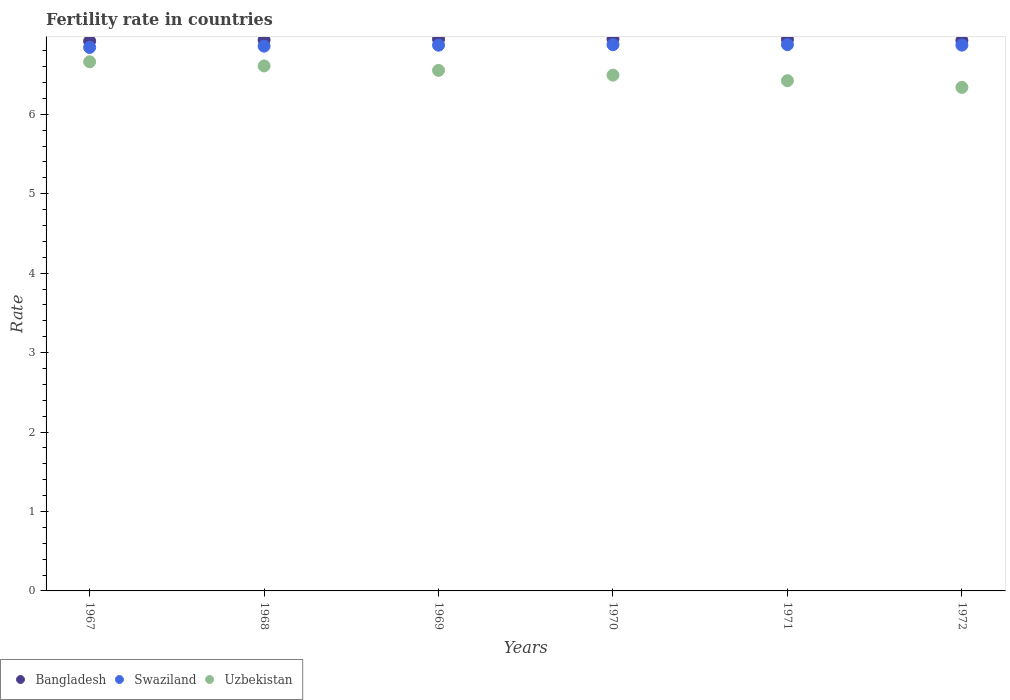How many different coloured dotlines are there?
Offer a very short reply. 3. What is the fertility rate in Uzbekistan in 1968?
Keep it short and to the point. 6.61. Across all years, what is the maximum fertility rate in Bangladesh?
Provide a short and direct response. 6.95. Across all years, what is the minimum fertility rate in Swaziland?
Your answer should be compact. 6.84. In which year was the fertility rate in Swaziland maximum?
Keep it short and to the point. 1971. In which year was the fertility rate in Swaziland minimum?
Your answer should be compact. 1967. What is the total fertility rate in Swaziland in the graph?
Ensure brevity in your answer.  41.19. What is the difference between the fertility rate in Uzbekistan in 1969 and that in 1971?
Give a very brief answer. 0.13. What is the difference between the fertility rate in Uzbekistan in 1969 and the fertility rate in Bangladesh in 1970?
Make the answer very short. -0.4. What is the average fertility rate in Swaziland per year?
Offer a terse response. 6.86. In the year 1971, what is the difference between the fertility rate in Uzbekistan and fertility rate in Swaziland?
Your answer should be compact. -0.45. In how many years, is the fertility rate in Bangladesh greater than 2.6?
Your answer should be very brief. 6. What is the ratio of the fertility rate in Uzbekistan in 1967 to that in 1970?
Your answer should be very brief. 1.03. Is the fertility rate in Bangladesh in 1967 less than that in 1972?
Your response must be concise. Yes. Is the difference between the fertility rate in Uzbekistan in 1968 and 1971 greater than the difference between the fertility rate in Swaziland in 1968 and 1971?
Your answer should be compact. Yes. What is the difference between the highest and the second highest fertility rate in Uzbekistan?
Give a very brief answer. 0.05. What is the difference between the highest and the lowest fertility rate in Swaziland?
Make the answer very short. 0.04. Is the sum of the fertility rate in Uzbekistan in 1967 and 1970 greater than the maximum fertility rate in Bangladesh across all years?
Ensure brevity in your answer.  Yes. Does the fertility rate in Uzbekistan monotonically increase over the years?
Your answer should be very brief. No. How many dotlines are there?
Your answer should be compact. 3. Are the values on the major ticks of Y-axis written in scientific E-notation?
Keep it short and to the point. No. Does the graph contain any zero values?
Offer a terse response. No. How many legend labels are there?
Keep it short and to the point. 3. What is the title of the graph?
Keep it short and to the point. Fertility rate in countries. What is the label or title of the X-axis?
Give a very brief answer. Years. What is the label or title of the Y-axis?
Provide a short and direct response. Rate. What is the Rate of Bangladesh in 1967?
Offer a terse response. 6.92. What is the Rate of Swaziland in 1967?
Ensure brevity in your answer.  6.84. What is the Rate of Uzbekistan in 1967?
Your answer should be very brief. 6.66. What is the Rate of Bangladesh in 1968?
Ensure brevity in your answer.  6.93. What is the Rate of Swaziland in 1968?
Provide a short and direct response. 6.86. What is the Rate in Uzbekistan in 1968?
Your answer should be very brief. 6.61. What is the Rate in Bangladesh in 1969?
Ensure brevity in your answer.  6.95. What is the Rate of Swaziland in 1969?
Your answer should be compact. 6.87. What is the Rate in Uzbekistan in 1969?
Give a very brief answer. 6.55. What is the Rate in Bangladesh in 1970?
Make the answer very short. 6.95. What is the Rate in Swaziland in 1970?
Offer a terse response. 6.88. What is the Rate in Uzbekistan in 1970?
Your answer should be very brief. 6.49. What is the Rate in Bangladesh in 1971?
Provide a short and direct response. 6.94. What is the Rate in Swaziland in 1971?
Offer a very short reply. 6.88. What is the Rate in Uzbekistan in 1971?
Ensure brevity in your answer.  6.42. What is the Rate of Bangladesh in 1972?
Keep it short and to the point. 6.93. What is the Rate of Swaziland in 1972?
Keep it short and to the point. 6.87. What is the Rate of Uzbekistan in 1972?
Provide a short and direct response. 6.34. Across all years, what is the maximum Rate in Bangladesh?
Offer a very short reply. 6.95. Across all years, what is the maximum Rate in Swaziland?
Your answer should be very brief. 6.88. Across all years, what is the maximum Rate of Uzbekistan?
Give a very brief answer. 6.66. Across all years, what is the minimum Rate in Bangladesh?
Provide a short and direct response. 6.92. Across all years, what is the minimum Rate of Swaziland?
Keep it short and to the point. 6.84. Across all years, what is the minimum Rate of Uzbekistan?
Your answer should be very brief. 6.34. What is the total Rate of Bangladesh in the graph?
Provide a succinct answer. 41.62. What is the total Rate of Swaziland in the graph?
Your response must be concise. 41.19. What is the total Rate of Uzbekistan in the graph?
Offer a terse response. 39.07. What is the difference between the Rate in Bangladesh in 1967 and that in 1968?
Keep it short and to the point. -0.01. What is the difference between the Rate of Swaziland in 1967 and that in 1968?
Your answer should be very brief. -0.02. What is the difference between the Rate of Uzbekistan in 1967 and that in 1968?
Keep it short and to the point. 0.05. What is the difference between the Rate in Bangladesh in 1967 and that in 1969?
Provide a succinct answer. -0.03. What is the difference between the Rate in Swaziland in 1967 and that in 1969?
Offer a very short reply. -0.03. What is the difference between the Rate of Uzbekistan in 1967 and that in 1969?
Your answer should be compact. 0.11. What is the difference between the Rate of Bangladesh in 1967 and that in 1970?
Provide a succinct answer. -0.03. What is the difference between the Rate of Swaziland in 1967 and that in 1970?
Your response must be concise. -0.03. What is the difference between the Rate of Uzbekistan in 1967 and that in 1970?
Give a very brief answer. 0.17. What is the difference between the Rate of Bangladesh in 1967 and that in 1971?
Your response must be concise. -0.02. What is the difference between the Rate in Swaziland in 1967 and that in 1971?
Offer a terse response. -0.04. What is the difference between the Rate of Uzbekistan in 1967 and that in 1971?
Your answer should be compact. 0.24. What is the difference between the Rate of Bangladesh in 1967 and that in 1972?
Your answer should be compact. -0.01. What is the difference between the Rate in Swaziland in 1967 and that in 1972?
Provide a succinct answer. -0.03. What is the difference between the Rate in Uzbekistan in 1967 and that in 1972?
Ensure brevity in your answer.  0.32. What is the difference between the Rate in Bangladesh in 1968 and that in 1969?
Provide a short and direct response. -0.01. What is the difference between the Rate of Swaziland in 1968 and that in 1969?
Ensure brevity in your answer.  -0.01. What is the difference between the Rate in Uzbekistan in 1968 and that in 1969?
Offer a very short reply. 0.06. What is the difference between the Rate of Bangladesh in 1968 and that in 1970?
Provide a short and direct response. -0.01. What is the difference between the Rate in Swaziland in 1968 and that in 1970?
Your answer should be compact. -0.02. What is the difference between the Rate in Uzbekistan in 1968 and that in 1970?
Offer a very short reply. 0.12. What is the difference between the Rate of Bangladesh in 1968 and that in 1971?
Offer a very short reply. -0.01. What is the difference between the Rate of Swaziland in 1968 and that in 1971?
Provide a short and direct response. -0.02. What is the difference between the Rate in Uzbekistan in 1968 and that in 1971?
Offer a very short reply. 0.19. What is the difference between the Rate in Bangladesh in 1968 and that in 1972?
Your response must be concise. 0.01. What is the difference between the Rate in Swaziland in 1968 and that in 1972?
Provide a succinct answer. -0.01. What is the difference between the Rate of Uzbekistan in 1968 and that in 1972?
Offer a terse response. 0.27. What is the difference between the Rate of Bangladesh in 1969 and that in 1970?
Give a very brief answer. -0. What is the difference between the Rate of Swaziland in 1969 and that in 1970?
Your answer should be very brief. -0.01. What is the difference between the Rate in Uzbekistan in 1969 and that in 1970?
Make the answer very short. 0.06. What is the difference between the Rate in Bangladesh in 1969 and that in 1971?
Keep it short and to the point. 0. What is the difference between the Rate of Swaziland in 1969 and that in 1971?
Provide a short and direct response. -0.01. What is the difference between the Rate of Uzbekistan in 1969 and that in 1971?
Offer a terse response. 0.13. What is the difference between the Rate in Bangladesh in 1969 and that in 1972?
Provide a succinct answer. 0.02. What is the difference between the Rate in Swaziland in 1969 and that in 1972?
Ensure brevity in your answer.  -0. What is the difference between the Rate in Uzbekistan in 1969 and that in 1972?
Make the answer very short. 0.21. What is the difference between the Rate in Bangladesh in 1970 and that in 1971?
Your answer should be very brief. 0.01. What is the difference between the Rate of Swaziland in 1970 and that in 1971?
Offer a terse response. -0. What is the difference between the Rate in Uzbekistan in 1970 and that in 1971?
Offer a very short reply. 0.07. What is the difference between the Rate of Bangladesh in 1970 and that in 1972?
Your answer should be very brief. 0.02. What is the difference between the Rate of Swaziland in 1970 and that in 1972?
Ensure brevity in your answer.  0.01. What is the difference between the Rate of Uzbekistan in 1970 and that in 1972?
Your answer should be compact. 0.15. What is the difference between the Rate of Bangladesh in 1971 and that in 1972?
Ensure brevity in your answer.  0.01. What is the difference between the Rate of Swaziland in 1971 and that in 1972?
Your answer should be very brief. 0.01. What is the difference between the Rate in Uzbekistan in 1971 and that in 1972?
Your answer should be compact. 0.08. What is the difference between the Rate of Bangladesh in 1967 and the Rate of Swaziland in 1968?
Give a very brief answer. 0.06. What is the difference between the Rate of Bangladesh in 1967 and the Rate of Uzbekistan in 1968?
Make the answer very short. 0.31. What is the difference between the Rate of Swaziland in 1967 and the Rate of Uzbekistan in 1968?
Your answer should be compact. 0.23. What is the difference between the Rate of Bangladesh in 1967 and the Rate of Swaziland in 1969?
Offer a very short reply. 0.05. What is the difference between the Rate of Bangladesh in 1967 and the Rate of Uzbekistan in 1969?
Keep it short and to the point. 0.37. What is the difference between the Rate in Swaziland in 1967 and the Rate in Uzbekistan in 1969?
Offer a terse response. 0.29. What is the difference between the Rate in Bangladesh in 1967 and the Rate in Swaziland in 1970?
Your answer should be very brief. 0.04. What is the difference between the Rate in Bangladesh in 1967 and the Rate in Uzbekistan in 1970?
Ensure brevity in your answer.  0.43. What is the difference between the Rate in Swaziland in 1967 and the Rate in Uzbekistan in 1970?
Offer a terse response. 0.35. What is the difference between the Rate in Bangladesh in 1967 and the Rate in Swaziland in 1971?
Provide a succinct answer. 0.04. What is the difference between the Rate in Bangladesh in 1967 and the Rate in Uzbekistan in 1971?
Ensure brevity in your answer.  0.5. What is the difference between the Rate in Swaziland in 1967 and the Rate in Uzbekistan in 1971?
Offer a very short reply. 0.42. What is the difference between the Rate in Bangladesh in 1967 and the Rate in Swaziland in 1972?
Ensure brevity in your answer.  0.05. What is the difference between the Rate in Bangladesh in 1967 and the Rate in Uzbekistan in 1972?
Ensure brevity in your answer.  0.58. What is the difference between the Rate in Swaziland in 1967 and the Rate in Uzbekistan in 1972?
Ensure brevity in your answer.  0.5. What is the difference between the Rate in Bangladesh in 1968 and the Rate in Swaziland in 1969?
Your response must be concise. 0.07. What is the difference between the Rate of Bangladesh in 1968 and the Rate of Uzbekistan in 1969?
Offer a very short reply. 0.38. What is the difference between the Rate of Swaziland in 1968 and the Rate of Uzbekistan in 1969?
Offer a very short reply. 0.3. What is the difference between the Rate of Bangladesh in 1968 and the Rate of Swaziland in 1970?
Offer a very short reply. 0.06. What is the difference between the Rate of Bangladesh in 1968 and the Rate of Uzbekistan in 1970?
Offer a very short reply. 0.44. What is the difference between the Rate of Swaziland in 1968 and the Rate of Uzbekistan in 1970?
Provide a succinct answer. 0.36. What is the difference between the Rate in Bangladesh in 1968 and the Rate in Swaziland in 1971?
Your answer should be very brief. 0.06. What is the difference between the Rate of Bangladesh in 1968 and the Rate of Uzbekistan in 1971?
Give a very brief answer. 0.51. What is the difference between the Rate in Swaziland in 1968 and the Rate in Uzbekistan in 1971?
Make the answer very short. 0.43. What is the difference between the Rate in Bangladesh in 1968 and the Rate in Swaziland in 1972?
Give a very brief answer. 0.07. What is the difference between the Rate in Bangladesh in 1968 and the Rate in Uzbekistan in 1972?
Offer a terse response. 0.6. What is the difference between the Rate of Swaziland in 1968 and the Rate of Uzbekistan in 1972?
Your answer should be compact. 0.52. What is the difference between the Rate of Bangladesh in 1969 and the Rate of Swaziland in 1970?
Give a very brief answer. 0.07. What is the difference between the Rate in Bangladesh in 1969 and the Rate in Uzbekistan in 1970?
Your answer should be very brief. 0.45. What is the difference between the Rate in Swaziland in 1969 and the Rate in Uzbekistan in 1970?
Your response must be concise. 0.38. What is the difference between the Rate of Bangladesh in 1969 and the Rate of Swaziland in 1971?
Your answer should be compact. 0.07. What is the difference between the Rate of Bangladesh in 1969 and the Rate of Uzbekistan in 1971?
Make the answer very short. 0.52. What is the difference between the Rate in Swaziland in 1969 and the Rate in Uzbekistan in 1971?
Offer a terse response. 0.45. What is the difference between the Rate in Bangladesh in 1969 and the Rate in Swaziland in 1972?
Make the answer very short. 0.07. What is the difference between the Rate of Bangladesh in 1969 and the Rate of Uzbekistan in 1972?
Offer a very short reply. 0.61. What is the difference between the Rate of Swaziland in 1969 and the Rate of Uzbekistan in 1972?
Give a very brief answer. 0.53. What is the difference between the Rate of Bangladesh in 1970 and the Rate of Swaziland in 1971?
Provide a succinct answer. 0.07. What is the difference between the Rate of Bangladesh in 1970 and the Rate of Uzbekistan in 1971?
Your response must be concise. 0.53. What is the difference between the Rate of Swaziland in 1970 and the Rate of Uzbekistan in 1971?
Provide a short and direct response. 0.45. What is the difference between the Rate of Bangladesh in 1970 and the Rate of Swaziland in 1972?
Give a very brief answer. 0.08. What is the difference between the Rate in Bangladesh in 1970 and the Rate in Uzbekistan in 1972?
Give a very brief answer. 0.61. What is the difference between the Rate of Swaziland in 1970 and the Rate of Uzbekistan in 1972?
Make the answer very short. 0.54. What is the difference between the Rate in Bangladesh in 1971 and the Rate in Swaziland in 1972?
Your answer should be compact. 0.07. What is the difference between the Rate of Bangladesh in 1971 and the Rate of Uzbekistan in 1972?
Ensure brevity in your answer.  0.6. What is the difference between the Rate of Swaziland in 1971 and the Rate of Uzbekistan in 1972?
Make the answer very short. 0.54. What is the average Rate in Bangladesh per year?
Provide a short and direct response. 6.94. What is the average Rate in Swaziland per year?
Provide a short and direct response. 6.86. What is the average Rate in Uzbekistan per year?
Ensure brevity in your answer.  6.51. In the year 1967, what is the difference between the Rate in Bangladesh and Rate in Swaziland?
Offer a very short reply. 0.08. In the year 1967, what is the difference between the Rate of Bangladesh and Rate of Uzbekistan?
Your answer should be compact. 0.26. In the year 1967, what is the difference between the Rate of Swaziland and Rate of Uzbekistan?
Give a very brief answer. 0.18. In the year 1968, what is the difference between the Rate of Bangladesh and Rate of Swaziland?
Your answer should be compact. 0.08. In the year 1968, what is the difference between the Rate in Bangladesh and Rate in Uzbekistan?
Give a very brief answer. 0.33. In the year 1968, what is the difference between the Rate of Swaziland and Rate of Uzbekistan?
Your answer should be very brief. 0.25. In the year 1969, what is the difference between the Rate in Bangladesh and Rate in Swaziland?
Make the answer very short. 0.08. In the year 1969, what is the difference between the Rate in Bangladesh and Rate in Uzbekistan?
Provide a succinct answer. 0.39. In the year 1969, what is the difference between the Rate of Swaziland and Rate of Uzbekistan?
Make the answer very short. 0.32. In the year 1970, what is the difference between the Rate in Bangladesh and Rate in Swaziland?
Offer a terse response. 0.07. In the year 1970, what is the difference between the Rate in Bangladesh and Rate in Uzbekistan?
Offer a very short reply. 0.46. In the year 1970, what is the difference between the Rate in Swaziland and Rate in Uzbekistan?
Make the answer very short. 0.38. In the year 1971, what is the difference between the Rate of Bangladesh and Rate of Swaziland?
Give a very brief answer. 0.07. In the year 1971, what is the difference between the Rate in Bangladesh and Rate in Uzbekistan?
Keep it short and to the point. 0.52. In the year 1971, what is the difference between the Rate in Swaziland and Rate in Uzbekistan?
Provide a succinct answer. 0.45. In the year 1972, what is the difference between the Rate in Bangladesh and Rate in Swaziland?
Provide a succinct answer. 0.06. In the year 1972, what is the difference between the Rate in Bangladesh and Rate in Uzbekistan?
Keep it short and to the point. 0.59. In the year 1972, what is the difference between the Rate of Swaziland and Rate of Uzbekistan?
Give a very brief answer. 0.53. What is the ratio of the Rate of Bangladesh in 1967 to that in 1968?
Your response must be concise. 1. What is the ratio of the Rate in Swaziland in 1967 to that in 1968?
Provide a succinct answer. 1. What is the ratio of the Rate of Uzbekistan in 1967 to that in 1968?
Provide a succinct answer. 1.01. What is the ratio of the Rate in Bangladesh in 1967 to that in 1969?
Make the answer very short. 1. What is the ratio of the Rate of Swaziland in 1967 to that in 1969?
Provide a short and direct response. 1. What is the ratio of the Rate in Uzbekistan in 1967 to that in 1969?
Provide a succinct answer. 1.02. What is the ratio of the Rate in Bangladesh in 1967 to that in 1970?
Provide a succinct answer. 1. What is the ratio of the Rate in Uzbekistan in 1967 to that in 1970?
Your response must be concise. 1.03. What is the ratio of the Rate of Uzbekistan in 1967 to that in 1971?
Provide a short and direct response. 1.04. What is the ratio of the Rate in Swaziland in 1967 to that in 1972?
Offer a terse response. 1. What is the ratio of the Rate of Uzbekistan in 1967 to that in 1972?
Your answer should be compact. 1.05. What is the ratio of the Rate of Bangladesh in 1968 to that in 1969?
Your response must be concise. 1. What is the ratio of the Rate of Uzbekistan in 1968 to that in 1969?
Your response must be concise. 1.01. What is the ratio of the Rate in Bangladesh in 1968 to that in 1970?
Offer a very short reply. 1. What is the ratio of the Rate in Swaziland in 1968 to that in 1970?
Your answer should be very brief. 1. What is the ratio of the Rate of Uzbekistan in 1968 to that in 1970?
Your answer should be compact. 1.02. What is the ratio of the Rate of Bangladesh in 1968 to that in 1972?
Offer a very short reply. 1. What is the ratio of the Rate of Uzbekistan in 1968 to that in 1972?
Offer a terse response. 1.04. What is the ratio of the Rate of Bangladesh in 1969 to that in 1970?
Your response must be concise. 1. What is the ratio of the Rate in Uzbekistan in 1969 to that in 1970?
Your answer should be very brief. 1.01. What is the ratio of the Rate in Swaziland in 1969 to that in 1971?
Your response must be concise. 1. What is the ratio of the Rate of Uzbekistan in 1969 to that in 1971?
Keep it short and to the point. 1.02. What is the ratio of the Rate in Uzbekistan in 1969 to that in 1972?
Offer a terse response. 1.03. What is the ratio of the Rate of Swaziland in 1970 to that in 1971?
Provide a succinct answer. 1. What is the ratio of the Rate in Uzbekistan in 1970 to that in 1971?
Offer a terse response. 1.01. What is the ratio of the Rate of Bangladesh in 1970 to that in 1972?
Your answer should be very brief. 1. What is the ratio of the Rate of Uzbekistan in 1970 to that in 1972?
Keep it short and to the point. 1.02. What is the ratio of the Rate of Swaziland in 1971 to that in 1972?
Ensure brevity in your answer.  1. What is the ratio of the Rate in Uzbekistan in 1971 to that in 1972?
Your answer should be compact. 1.01. What is the difference between the highest and the second highest Rate in Bangladesh?
Your answer should be very brief. 0. What is the difference between the highest and the second highest Rate in Uzbekistan?
Your answer should be compact. 0.05. What is the difference between the highest and the lowest Rate in Bangladesh?
Keep it short and to the point. 0.03. What is the difference between the highest and the lowest Rate of Swaziland?
Your answer should be very brief. 0.04. What is the difference between the highest and the lowest Rate in Uzbekistan?
Offer a very short reply. 0.32. 